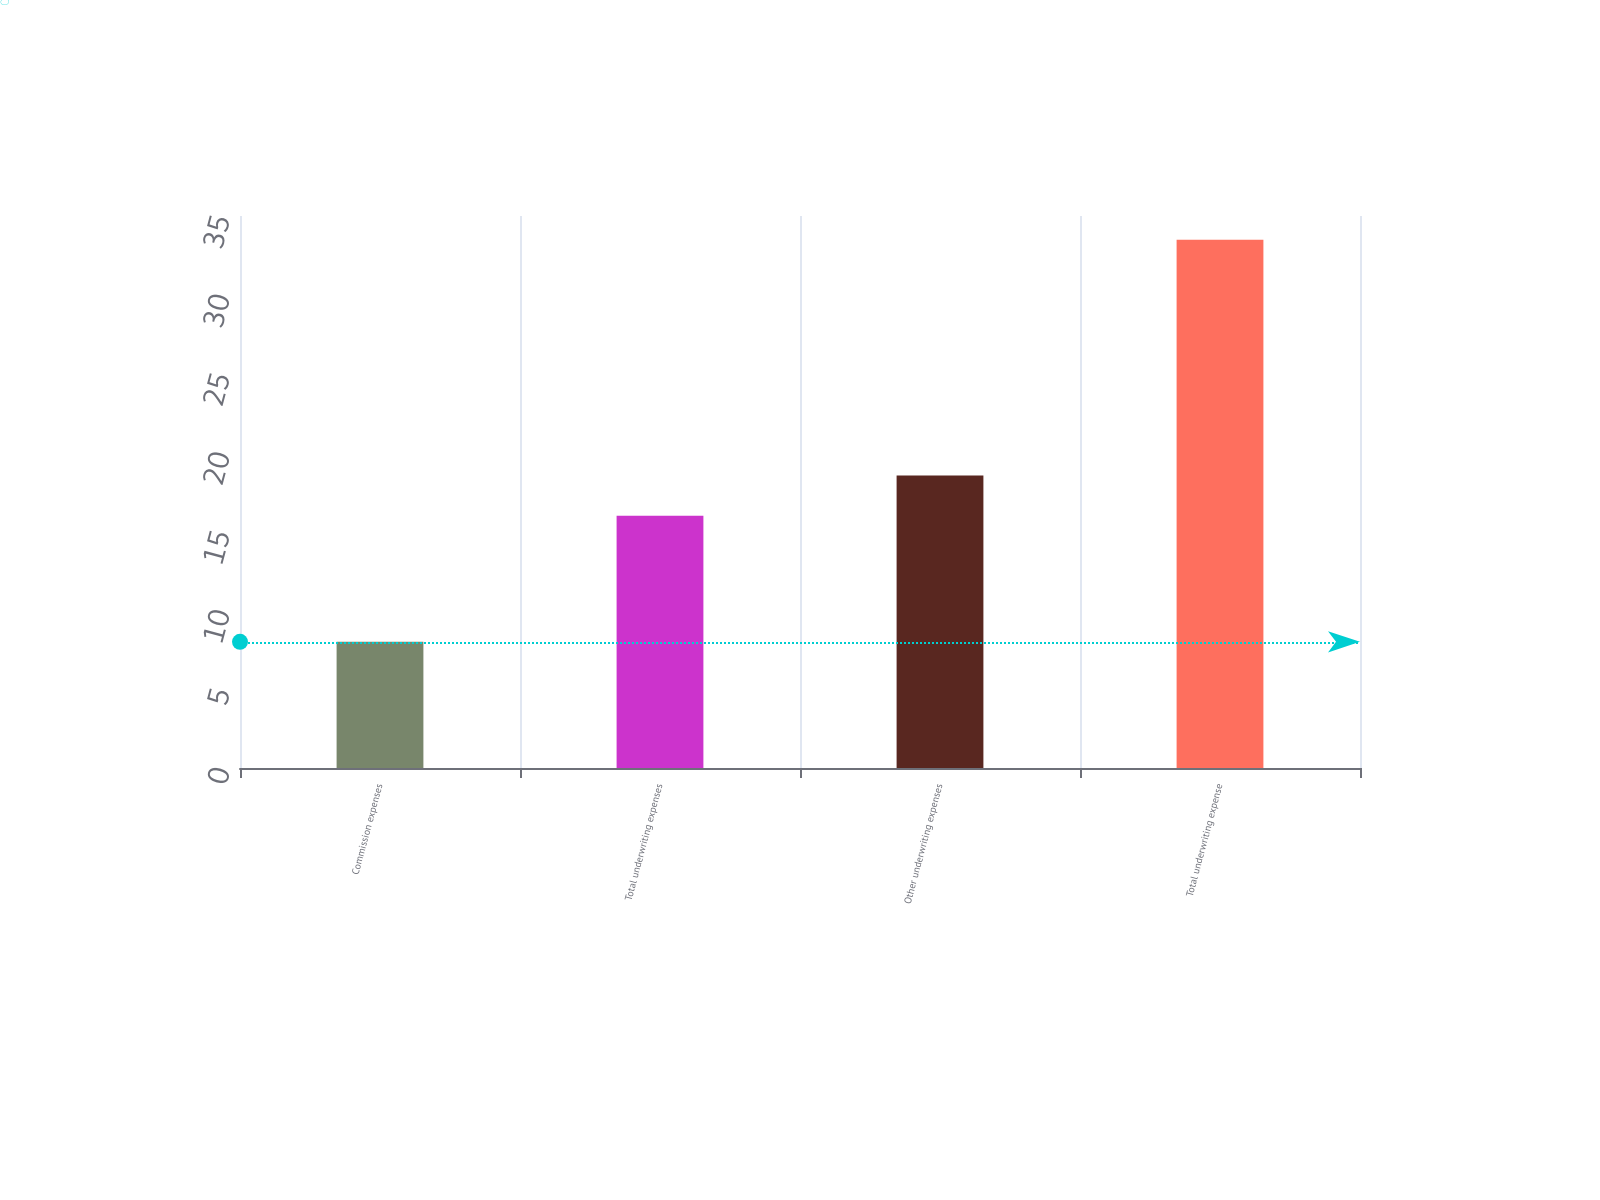Convert chart. <chart><loc_0><loc_0><loc_500><loc_500><bar_chart><fcel>Commission expenses<fcel>Total underwriting expenses<fcel>Other underwriting expenses<fcel>Total underwriting expense<nl><fcel>8<fcel>16<fcel>18.55<fcel>33.5<nl></chart> 